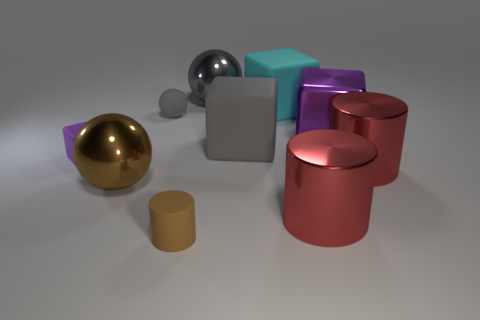There is a small matte sphere; is its color the same as the thing that is behind the big cyan object?
Ensure brevity in your answer.  Yes. What size is the other cube that is the same color as the tiny matte cube?
Your response must be concise. Large. Does the large rubber block that is to the left of the large cyan matte cube have the same color as the rubber sphere?
Give a very brief answer. Yes. What material is the other tiny object that is the same shape as the purple metal object?
Provide a short and direct response. Rubber. Is the shape of the tiny matte object that is behind the tiny purple cube the same as  the brown metal object?
Provide a short and direct response. Yes. What number of big red things are the same shape as the brown matte object?
Offer a terse response. 2. There is a rubber thing that is the same color as the metal cube; what is its shape?
Offer a very short reply. Cube. The brown rubber thing is what shape?
Your response must be concise. Cylinder. What number of big purple matte blocks are there?
Offer a very short reply. 0. What is the color of the large ball to the left of the matte cylinder in front of the purple matte block?
Your response must be concise. Brown. 